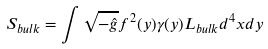<formula> <loc_0><loc_0><loc_500><loc_500>S _ { b u l k } = \int \sqrt { - \hat { g } } f ^ { 2 } ( y ) \gamma ( y ) L _ { b u l k } d ^ { 4 } x d y</formula> 